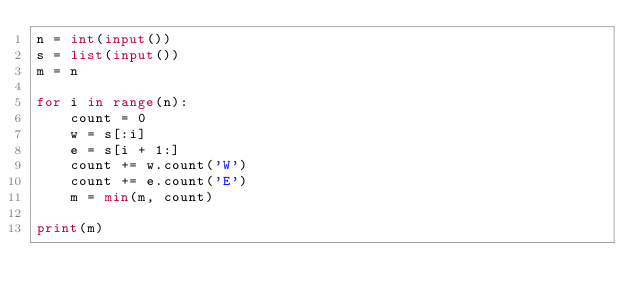Convert code to text. <code><loc_0><loc_0><loc_500><loc_500><_Python_>n = int(input())
s = list(input())
m = n

for i in range(n):
    count = 0
    w = s[:i]
    e = s[i + 1:]
    count += w.count('W')
    count += e.count('E')
    m = min(m, count)

print(m)</code> 